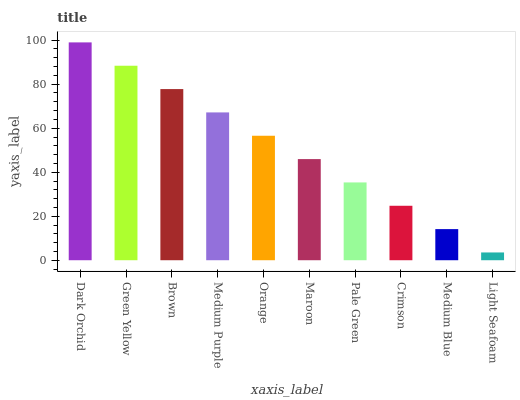Is Light Seafoam the minimum?
Answer yes or no. Yes. Is Dark Orchid the maximum?
Answer yes or no. Yes. Is Green Yellow the minimum?
Answer yes or no. No. Is Green Yellow the maximum?
Answer yes or no. No. Is Dark Orchid greater than Green Yellow?
Answer yes or no. Yes. Is Green Yellow less than Dark Orchid?
Answer yes or no. Yes. Is Green Yellow greater than Dark Orchid?
Answer yes or no. No. Is Dark Orchid less than Green Yellow?
Answer yes or no. No. Is Orange the high median?
Answer yes or no. Yes. Is Maroon the low median?
Answer yes or no. Yes. Is Dark Orchid the high median?
Answer yes or no. No. Is Pale Green the low median?
Answer yes or no. No. 